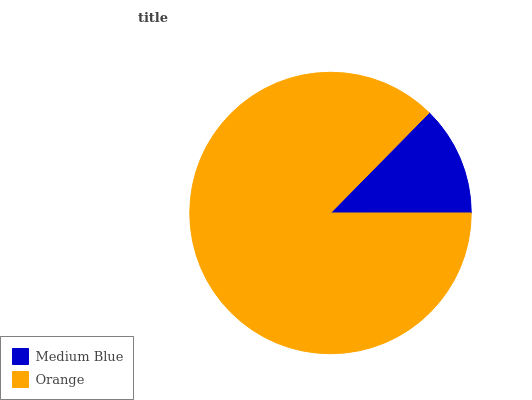Is Medium Blue the minimum?
Answer yes or no. Yes. Is Orange the maximum?
Answer yes or no. Yes. Is Orange the minimum?
Answer yes or no. No. Is Orange greater than Medium Blue?
Answer yes or no. Yes. Is Medium Blue less than Orange?
Answer yes or no. Yes. Is Medium Blue greater than Orange?
Answer yes or no. No. Is Orange less than Medium Blue?
Answer yes or no. No. Is Orange the high median?
Answer yes or no. Yes. Is Medium Blue the low median?
Answer yes or no. Yes. Is Medium Blue the high median?
Answer yes or no. No. Is Orange the low median?
Answer yes or no. No. 